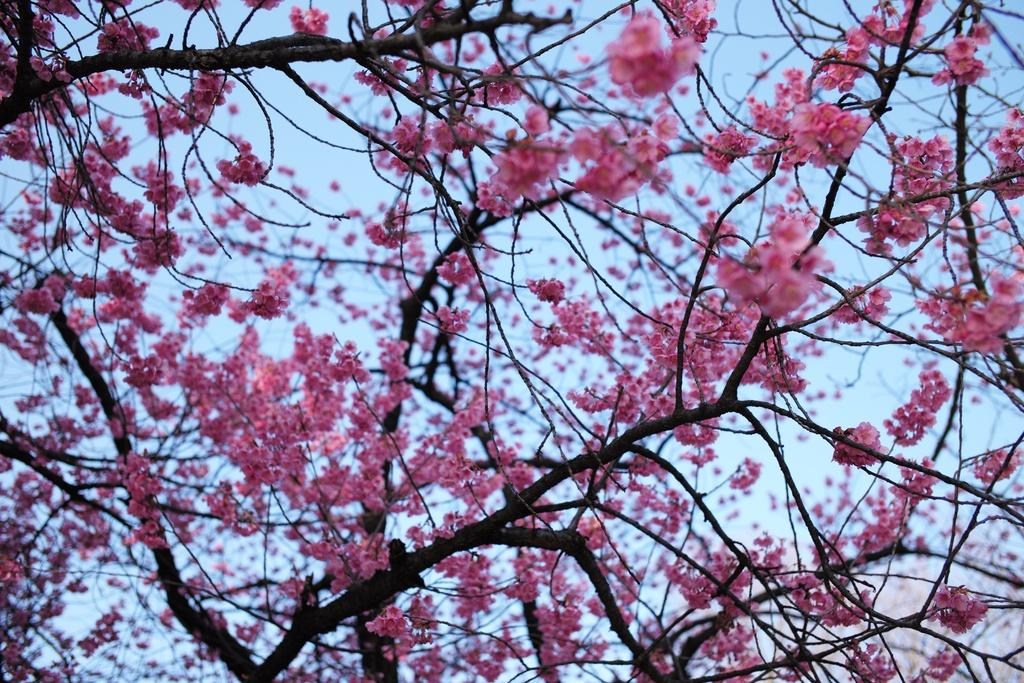What is the main subject of the image? The main subject of the image is a branch of a tree with many flowers. What can be seen in the background of the image? The background of the image is the sky. What is the opinion of the flowers about the ball in the room? There is no ball or room present in the image, and therefore no such interaction can be observed. 